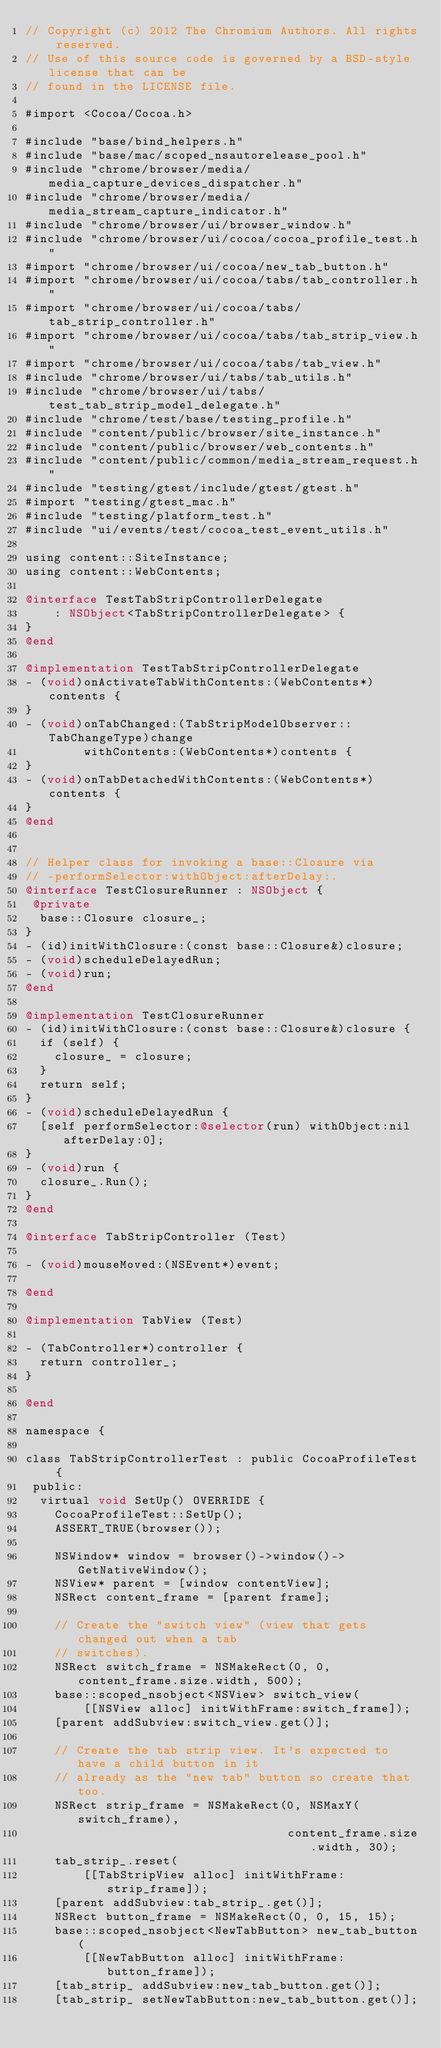Convert code to text. <code><loc_0><loc_0><loc_500><loc_500><_ObjectiveC_>// Copyright (c) 2012 The Chromium Authors. All rights reserved.
// Use of this source code is governed by a BSD-style license that can be
// found in the LICENSE file.

#import <Cocoa/Cocoa.h>

#include "base/bind_helpers.h"
#include "base/mac/scoped_nsautorelease_pool.h"
#include "chrome/browser/media/media_capture_devices_dispatcher.h"
#include "chrome/browser/media/media_stream_capture_indicator.h"
#include "chrome/browser/ui/browser_window.h"
#include "chrome/browser/ui/cocoa/cocoa_profile_test.h"
#import "chrome/browser/ui/cocoa/new_tab_button.h"
#import "chrome/browser/ui/cocoa/tabs/tab_controller.h"
#import "chrome/browser/ui/cocoa/tabs/tab_strip_controller.h"
#import "chrome/browser/ui/cocoa/tabs/tab_strip_view.h"
#import "chrome/browser/ui/cocoa/tabs/tab_view.h"
#include "chrome/browser/ui/tabs/tab_utils.h"
#include "chrome/browser/ui/tabs/test_tab_strip_model_delegate.h"
#include "chrome/test/base/testing_profile.h"
#include "content/public/browser/site_instance.h"
#include "content/public/browser/web_contents.h"
#include "content/public/common/media_stream_request.h"
#include "testing/gtest/include/gtest/gtest.h"
#import "testing/gtest_mac.h"
#include "testing/platform_test.h"
#include "ui/events/test/cocoa_test_event_utils.h"

using content::SiteInstance;
using content::WebContents;

@interface TestTabStripControllerDelegate
    : NSObject<TabStripControllerDelegate> {
}
@end

@implementation TestTabStripControllerDelegate
- (void)onActivateTabWithContents:(WebContents*)contents {
}
- (void)onTabChanged:(TabStripModelObserver::TabChangeType)change
        withContents:(WebContents*)contents {
}
- (void)onTabDetachedWithContents:(WebContents*)contents {
}
@end


// Helper class for invoking a base::Closure via
// -performSelector:withObject:afterDelay:.
@interface TestClosureRunner : NSObject {
 @private
  base::Closure closure_;
}
- (id)initWithClosure:(const base::Closure&)closure;
- (void)scheduleDelayedRun;
- (void)run;
@end

@implementation TestClosureRunner
- (id)initWithClosure:(const base::Closure&)closure {
  if (self) {
    closure_ = closure;
  }
  return self;
}
- (void)scheduleDelayedRun {
  [self performSelector:@selector(run) withObject:nil afterDelay:0];
}
- (void)run {
  closure_.Run();
}
@end

@interface TabStripController (Test)

- (void)mouseMoved:(NSEvent*)event;

@end

@implementation TabView (Test)

- (TabController*)controller {
  return controller_;
}

@end

namespace {

class TabStripControllerTest : public CocoaProfileTest {
 public:
  virtual void SetUp() OVERRIDE {
    CocoaProfileTest::SetUp();
    ASSERT_TRUE(browser());

    NSWindow* window = browser()->window()->GetNativeWindow();
    NSView* parent = [window contentView];
    NSRect content_frame = [parent frame];

    // Create the "switch view" (view that gets changed out when a tab
    // switches).
    NSRect switch_frame = NSMakeRect(0, 0, content_frame.size.width, 500);
    base::scoped_nsobject<NSView> switch_view(
        [[NSView alloc] initWithFrame:switch_frame]);
    [parent addSubview:switch_view.get()];

    // Create the tab strip view. It's expected to have a child button in it
    // already as the "new tab" button so create that too.
    NSRect strip_frame = NSMakeRect(0, NSMaxY(switch_frame),
                                    content_frame.size.width, 30);
    tab_strip_.reset(
        [[TabStripView alloc] initWithFrame:strip_frame]);
    [parent addSubview:tab_strip_.get()];
    NSRect button_frame = NSMakeRect(0, 0, 15, 15);
    base::scoped_nsobject<NewTabButton> new_tab_button(
        [[NewTabButton alloc] initWithFrame:button_frame]);
    [tab_strip_ addSubview:new_tab_button.get()];
    [tab_strip_ setNewTabButton:new_tab_button.get()];
</code> 